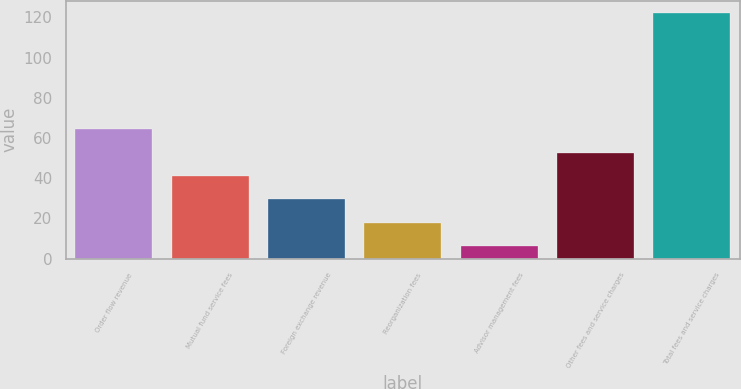Convert chart. <chart><loc_0><loc_0><loc_500><loc_500><bar_chart><fcel>Order flow revenue<fcel>Mutual fund service fees<fcel>Foreign exchange revenue<fcel>Reorganization fees<fcel>Advisor management fees<fcel>Other fees and service charges<fcel>Total fees and service charges<nl><fcel>64.3<fcel>41.14<fcel>29.56<fcel>17.98<fcel>6.4<fcel>52.72<fcel>122.2<nl></chart> 